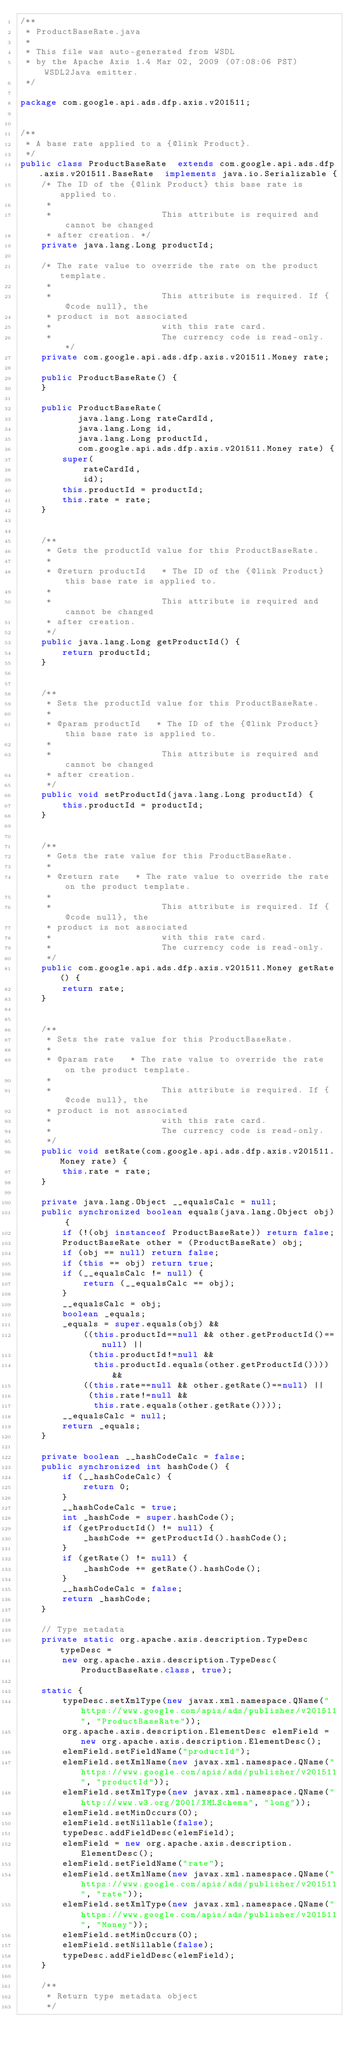Convert code to text. <code><loc_0><loc_0><loc_500><loc_500><_Java_>/**
 * ProductBaseRate.java
 *
 * This file was auto-generated from WSDL
 * by the Apache Axis 1.4 Mar 02, 2009 (07:08:06 PST) WSDL2Java emitter.
 */

package com.google.api.ads.dfp.axis.v201511;


/**
 * A base rate applied to a {@link Product}.
 */
public class ProductBaseRate  extends com.google.api.ads.dfp.axis.v201511.BaseRate  implements java.io.Serializable {
    /* The ID of the {@link Product} this base rate is applied to.
     * 
     *                     This attribute is required and cannot be changed
     * after creation. */
    private java.lang.Long productId;

    /* The rate value to override the rate on the product template.
     * 
     *                     This attribute is required. If {@code null}, the
     * product is not associated
     *                     with this rate card.
     *                     The currency code is read-only. */
    private com.google.api.ads.dfp.axis.v201511.Money rate;

    public ProductBaseRate() {
    }

    public ProductBaseRate(
           java.lang.Long rateCardId,
           java.lang.Long id,
           java.lang.Long productId,
           com.google.api.ads.dfp.axis.v201511.Money rate) {
        super(
            rateCardId,
            id);
        this.productId = productId;
        this.rate = rate;
    }


    /**
     * Gets the productId value for this ProductBaseRate.
     * 
     * @return productId   * The ID of the {@link Product} this base rate is applied to.
     * 
     *                     This attribute is required and cannot be changed
     * after creation.
     */
    public java.lang.Long getProductId() {
        return productId;
    }


    /**
     * Sets the productId value for this ProductBaseRate.
     * 
     * @param productId   * The ID of the {@link Product} this base rate is applied to.
     * 
     *                     This attribute is required and cannot be changed
     * after creation.
     */
    public void setProductId(java.lang.Long productId) {
        this.productId = productId;
    }


    /**
     * Gets the rate value for this ProductBaseRate.
     * 
     * @return rate   * The rate value to override the rate on the product template.
     * 
     *                     This attribute is required. If {@code null}, the
     * product is not associated
     *                     with this rate card.
     *                     The currency code is read-only.
     */
    public com.google.api.ads.dfp.axis.v201511.Money getRate() {
        return rate;
    }


    /**
     * Sets the rate value for this ProductBaseRate.
     * 
     * @param rate   * The rate value to override the rate on the product template.
     * 
     *                     This attribute is required. If {@code null}, the
     * product is not associated
     *                     with this rate card.
     *                     The currency code is read-only.
     */
    public void setRate(com.google.api.ads.dfp.axis.v201511.Money rate) {
        this.rate = rate;
    }

    private java.lang.Object __equalsCalc = null;
    public synchronized boolean equals(java.lang.Object obj) {
        if (!(obj instanceof ProductBaseRate)) return false;
        ProductBaseRate other = (ProductBaseRate) obj;
        if (obj == null) return false;
        if (this == obj) return true;
        if (__equalsCalc != null) {
            return (__equalsCalc == obj);
        }
        __equalsCalc = obj;
        boolean _equals;
        _equals = super.equals(obj) && 
            ((this.productId==null && other.getProductId()==null) || 
             (this.productId!=null &&
              this.productId.equals(other.getProductId()))) &&
            ((this.rate==null && other.getRate()==null) || 
             (this.rate!=null &&
              this.rate.equals(other.getRate())));
        __equalsCalc = null;
        return _equals;
    }

    private boolean __hashCodeCalc = false;
    public synchronized int hashCode() {
        if (__hashCodeCalc) {
            return 0;
        }
        __hashCodeCalc = true;
        int _hashCode = super.hashCode();
        if (getProductId() != null) {
            _hashCode += getProductId().hashCode();
        }
        if (getRate() != null) {
            _hashCode += getRate().hashCode();
        }
        __hashCodeCalc = false;
        return _hashCode;
    }

    // Type metadata
    private static org.apache.axis.description.TypeDesc typeDesc =
        new org.apache.axis.description.TypeDesc(ProductBaseRate.class, true);

    static {
        typeDesc.setXmlType(new javax.xml.namespace.QName("https://www.google.com/apis/ads/publisher/v201511", "ProductBaseRate"));
        org.apache.axis.description.ElementDesc elemField = new org.apache.axis.description.ElementDesc();
        elemField.setFieldName("productId");
        elemField.setXmlName(new javax.xml.namespace.QName("https://www.google.com/apis/ads/publisher/v201511", "productId"));
        elemField.setXmlType(new javax.xml.namespace.QName("http://www.w3.org/2001/XMLSchema", "long"));
        elemField.setMinOccurs(0);
        elemField.setNillable(false);
        typeDesc.addFieldDesc(elemField);
        elemField = new org.apache.axis.description.ElementDesc();
        elemField.setFieldName("rate");
        elemField.setXmlName(new javax.xml.namespace.QName("https://www.google.com/apis/ads/publisher/v201511", "rate"));
        elemField.setXmlType(new javax.xml.namespace.QName("https://www.google.com/apis/ads/publisher/v201511", "Money"));
        elemField.setMinOccurs(0);
        elemField.setNillable(false);
        typeDesc.addFieldDesc(elemField);
    }

    /**
     * Return type metadata object
     */</code> 